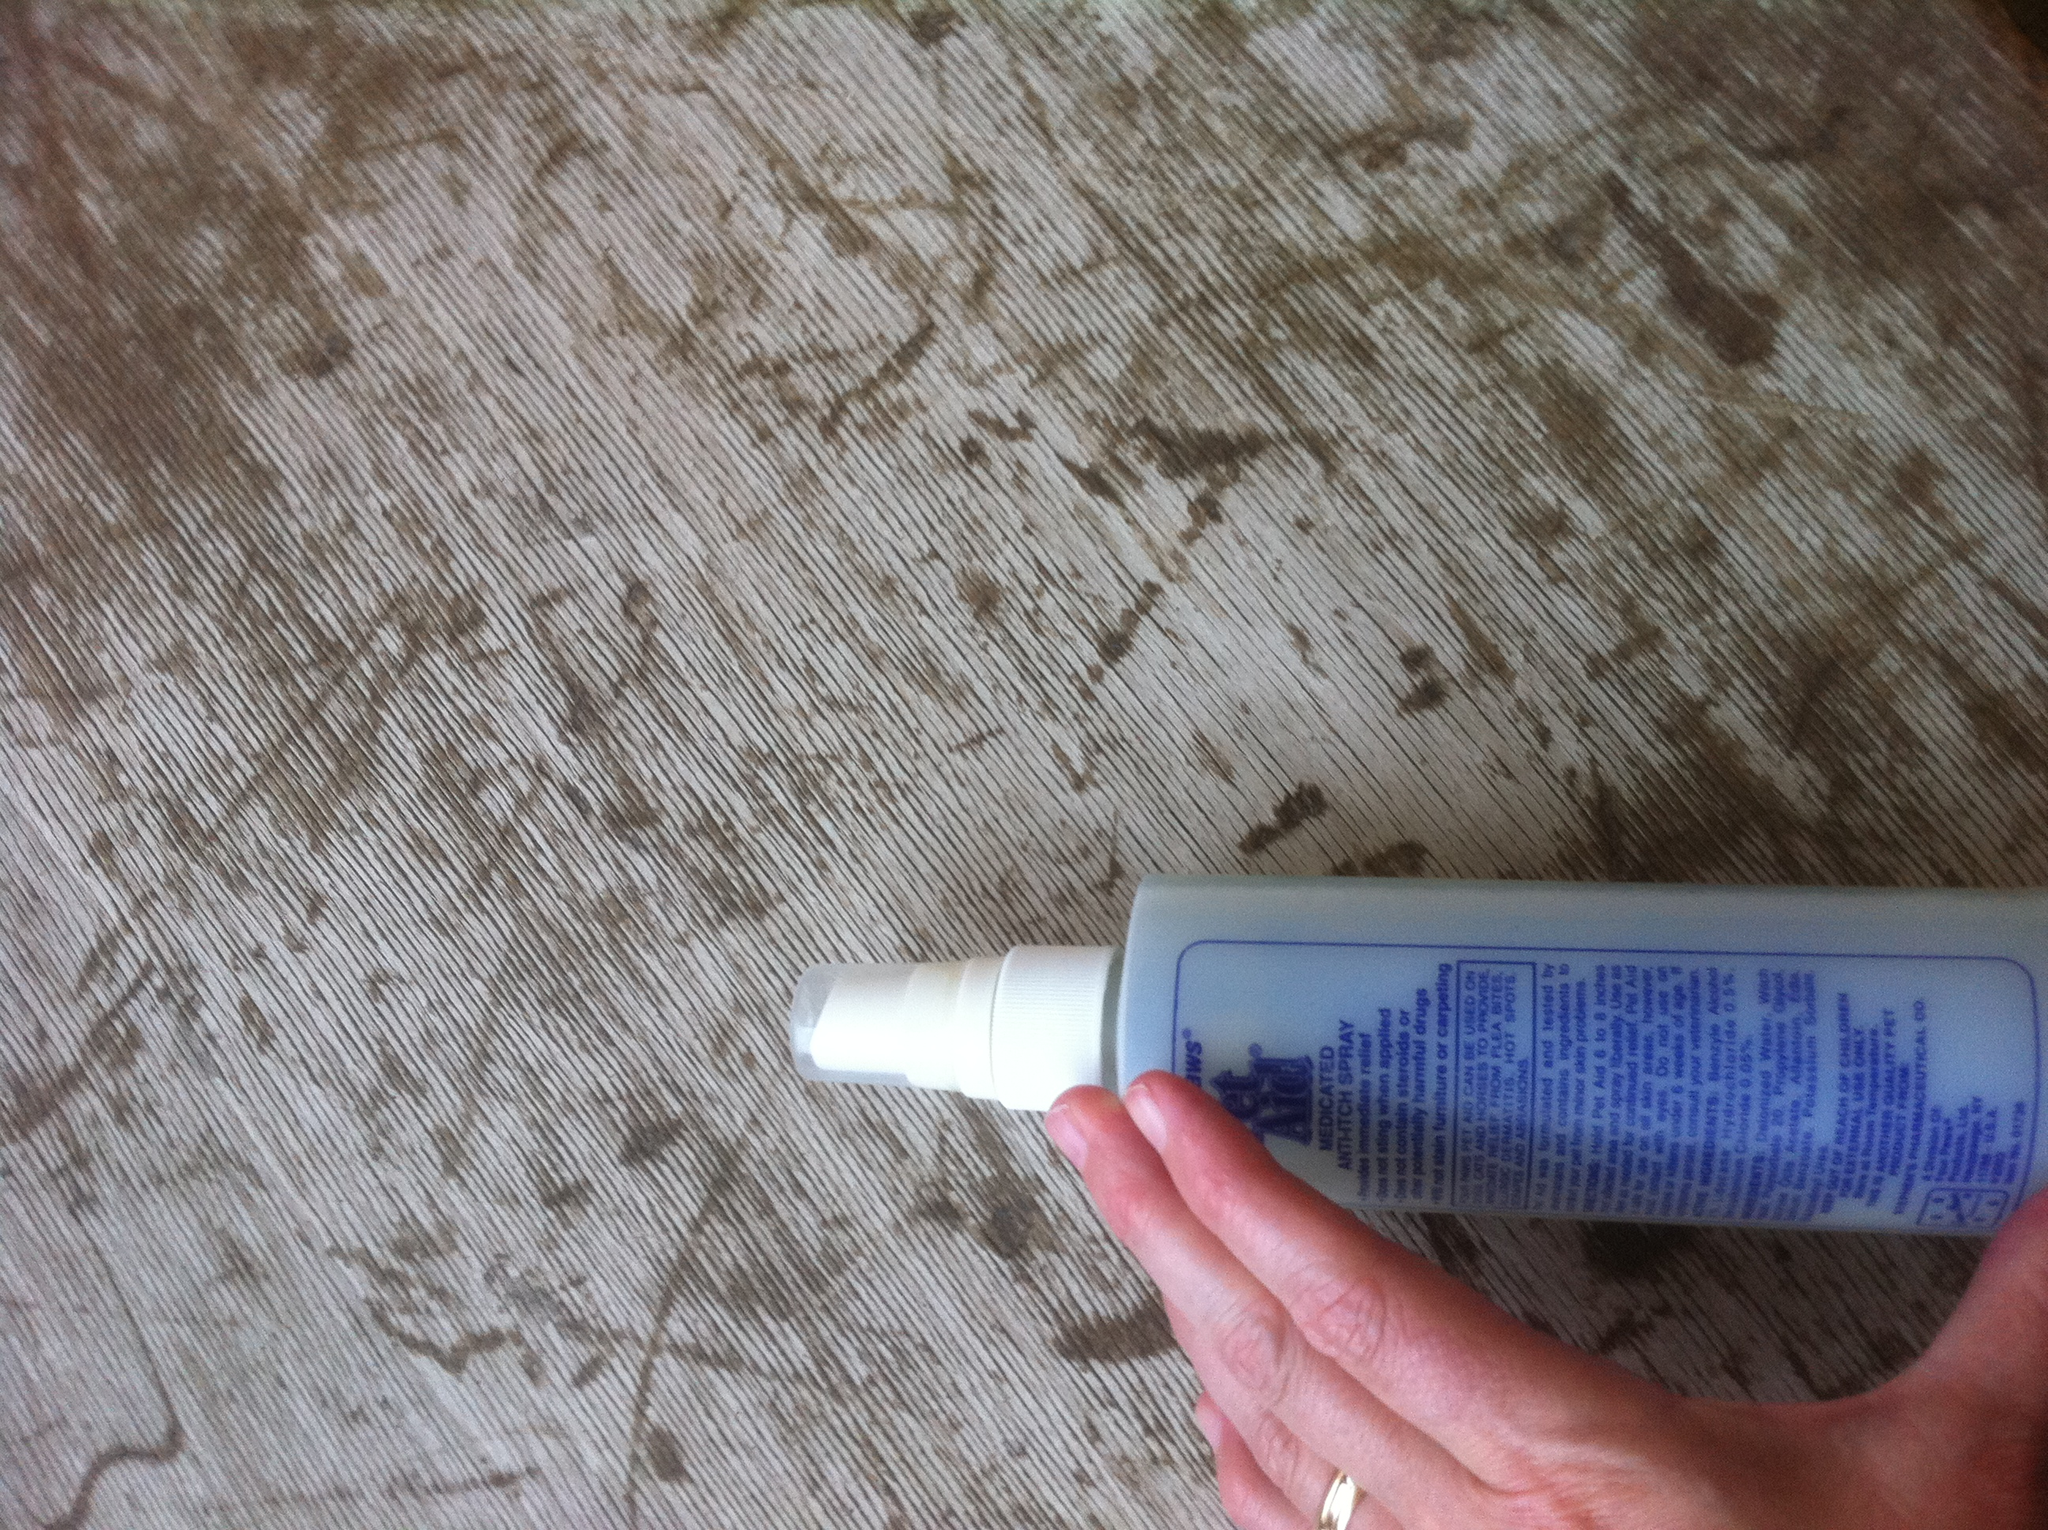What are the key ingredients in this dog product? The key ingredients in this dog product typically include soothing agents like aloe vera and natural extracts known for their calming properties. It may also contain mild antiseptics and moisturizers aimed at promoting skin health and preventing infections. Can this product be used on other pets like cats? It's crucial to check the label before using this product on other pets. Some ingredients safe for dogs may not be suitable for cats or other animals. Always consult your veterinarian if you are unsure about using the product on different pets. 